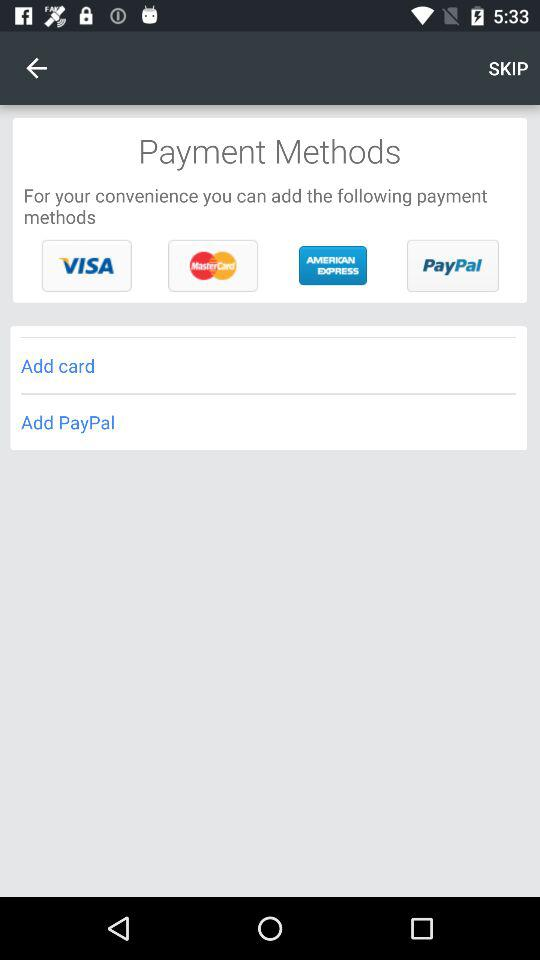What are the payment methods available? The payment methods are "VISA", "MasterCard", "AMERICAN EXPRESS" and "PayPal". 